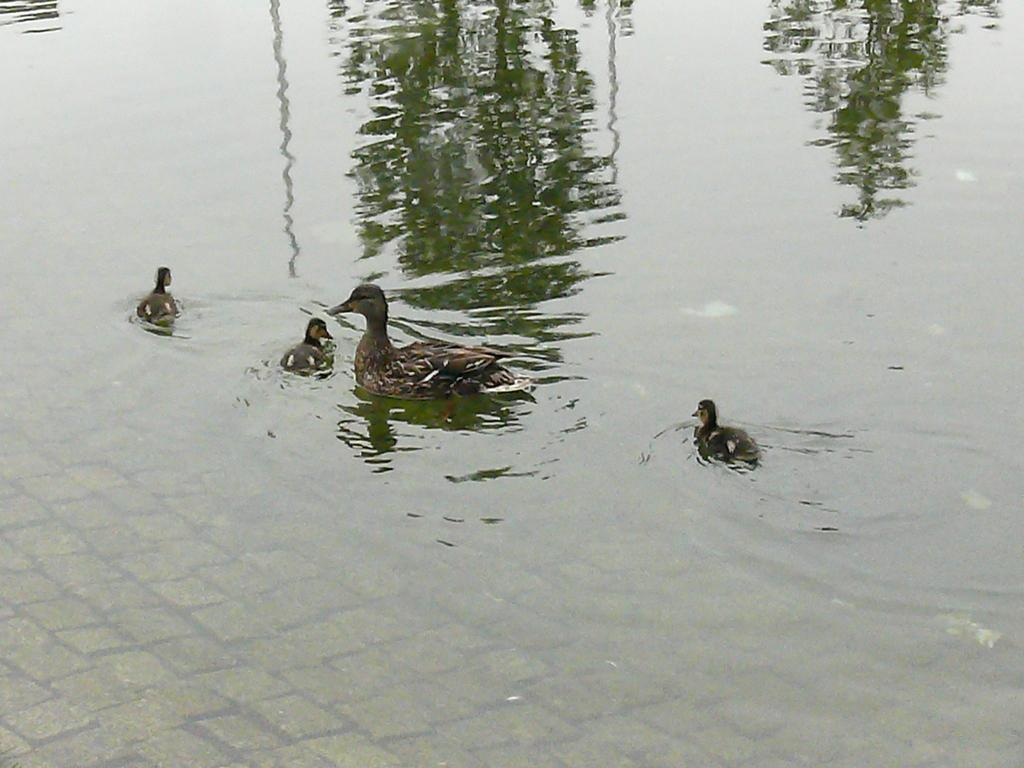What type of animals are present in the image? There are ducklings and a duck in the image. What are the ducklings and duck doing in the image? The ducklings and duck are swimming in the water. What is visible in the background of the image? Water is visible in the image. How many children are playing with the wrench in the image? There are no children or wrenches present in the image; it features ducklings and a duck swimming in water. 